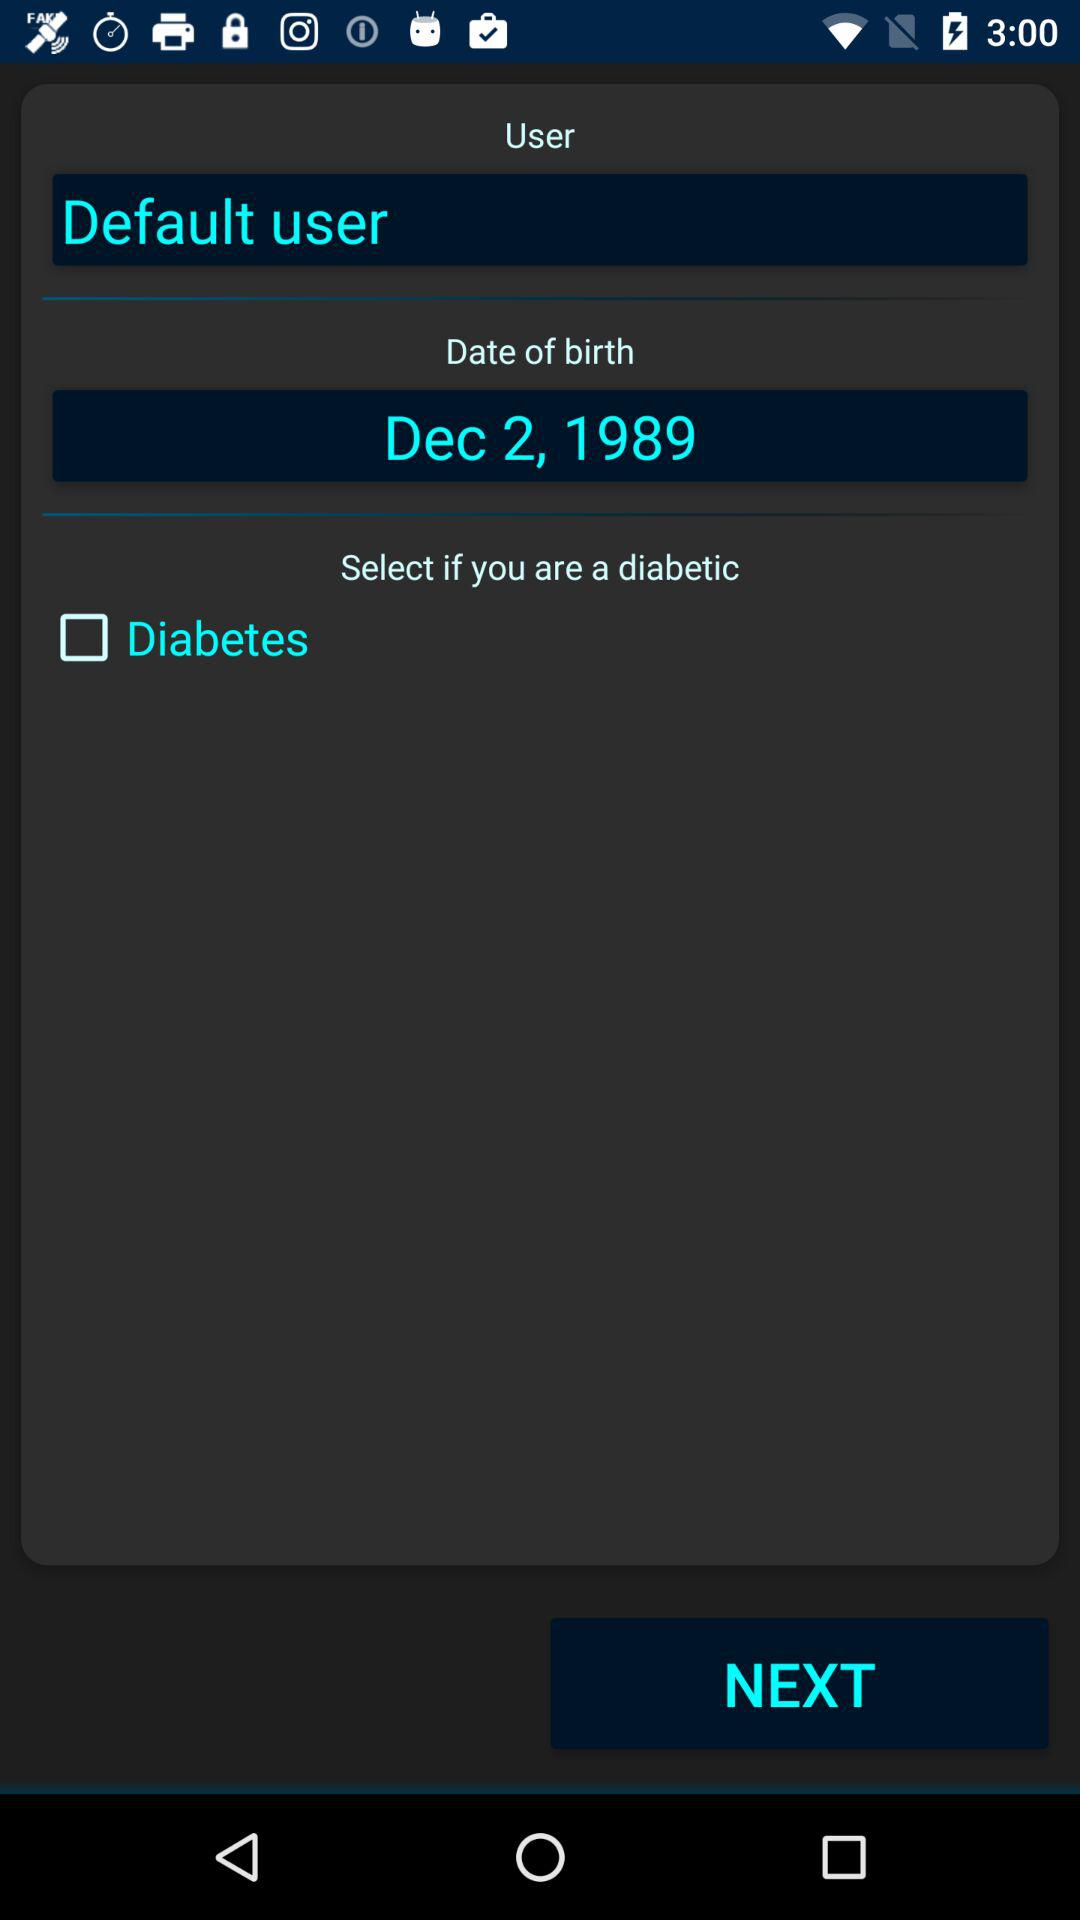Who is the user? The user is "Default user". 